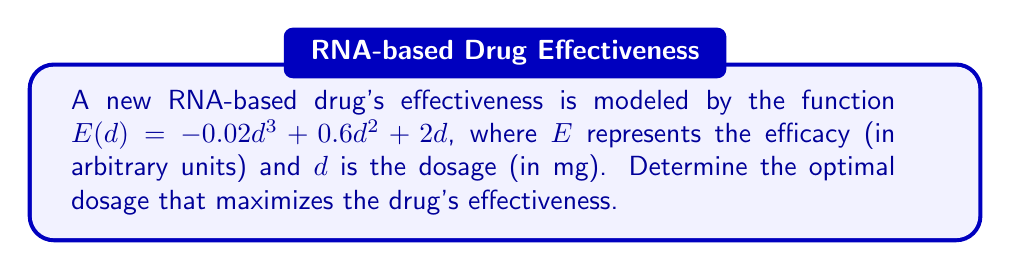Provide a solution to this math problem. To find the optimal dosage, we need to determine the maximum point of the function $E(d)$. This can be done by finding where the derivative of $E(d)$ equals zero.

Step 1: Calculate the derivative of $E(d)$
$$E'(d) = -0.06d^2 + 1.2d + 2$$

Step 2: Set $E'(d) = 0$ and solve for $d$
$$-0.06d^2 + 1.2d + 2 = 0$$

Step 3: Use the quadratic formula to solve this equation
$$d = \frac{-b \pm \sqrt{b^2 - 4ac}}{2a}$$
Where $a = -0.06$, $b = 1.2$, and $c = 2$

$$d = \frac{-1.2 \pm \sqrt{1.44 - 4(-0.06)(2)}}{2(-0.06)}$$
$$d = \frac{-1.2 \pm \sqrt{1.44 + 0.48}}{-0.12}$$
$$d = \frac{-1.2 \pm \sqrt{1.92}}{-0.12}$$
$$d = \frac{-1.2 \pm 1.3856}{-0.12}$$

This gives us two solutions:
$$d_1 = \frac{-1.2 + 1.3856}{-0.12} \approx 1.55$$
$$d_2 = \frac{-1.2 - 1.3856}{-0.12} \approx 21.55$$

Step 4: Determine which solution maximizes $E(d)$
To do this, we can check the second derivative at each point:
$$E''(d) = -0.12d + 1.2$$

At $d_1 = 1.55$: $E''(1.55) = -0.12(1.55) + 1.2 = 1.014 > 0$
At $d_2 = 21.55$: $E''(21.55) = -0.12(21.55) + 1.2 = -1.386 < 0$

Since $E''(d_1) > 0$, $d_1 = 1.55$ is a local minimum.
Since $E''(d_2) < 0$, $d_2 = 21.55$ is a local maximum.

Therefore, the optimal dosage that maximizes the drug's effectiveness is approximately 21.55 mg.
Answer: 21.55 mg 